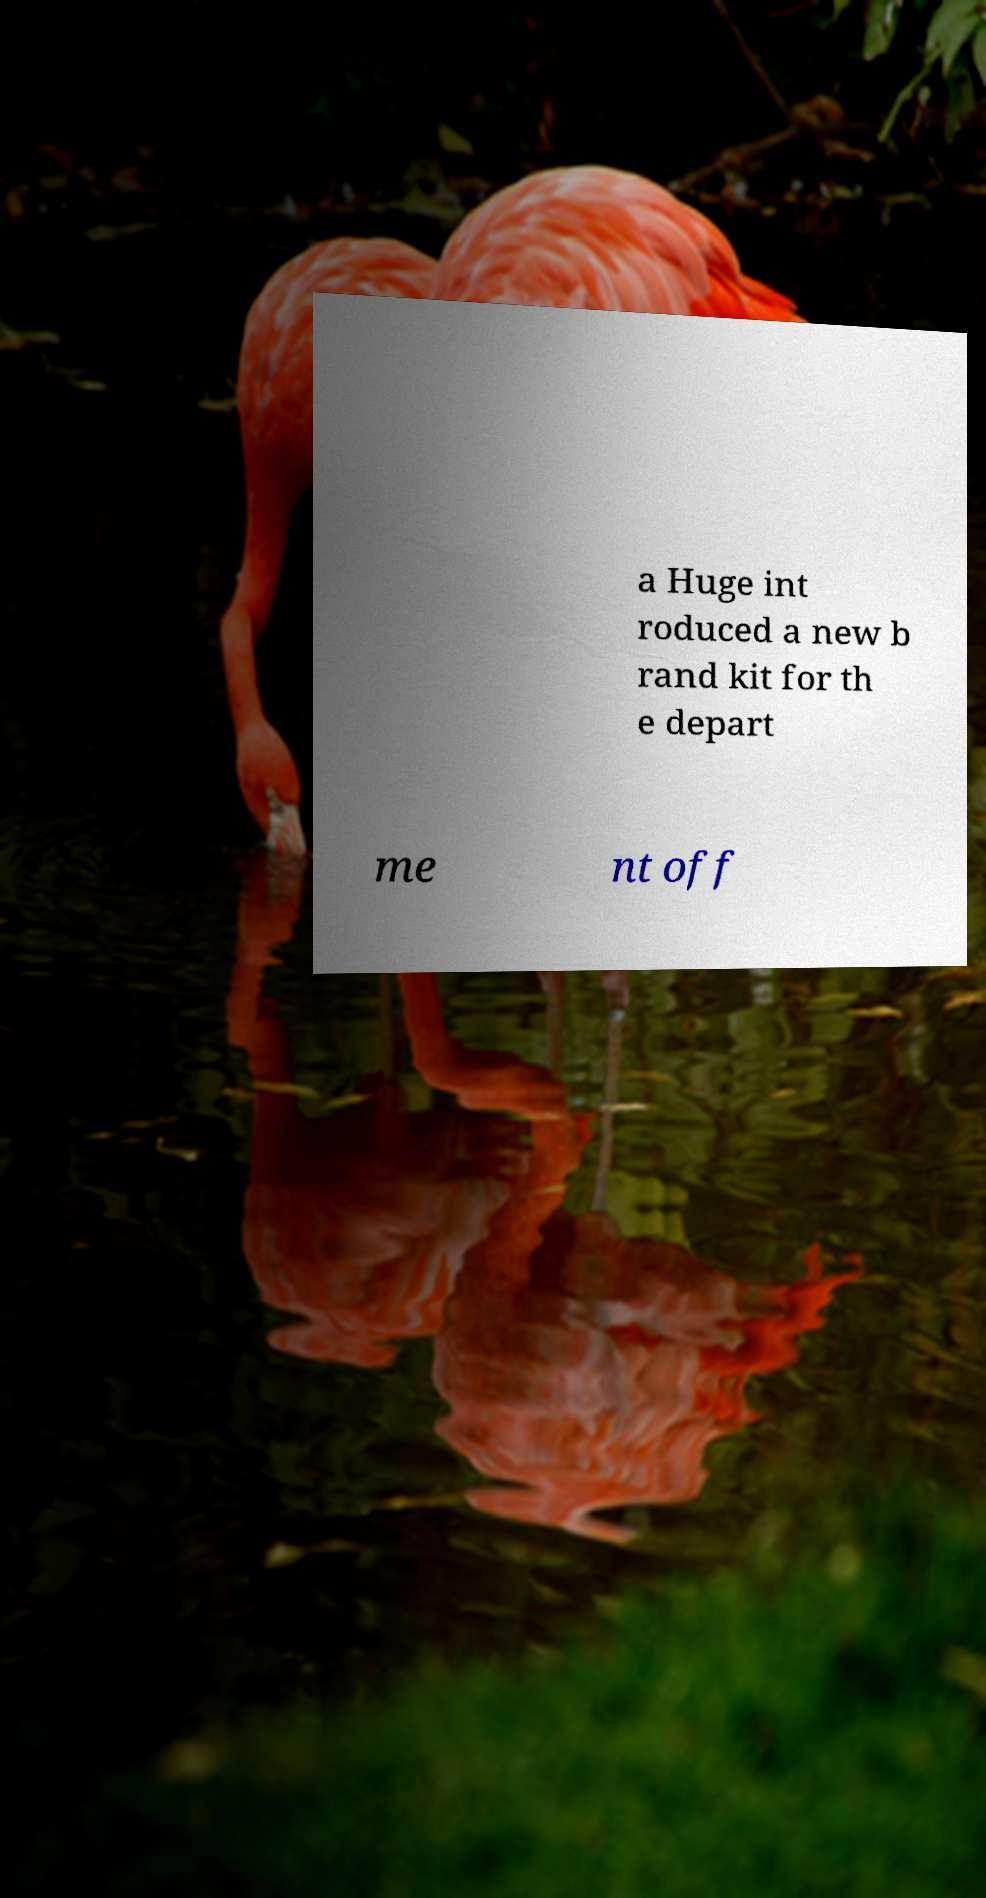Could you assist in decoding the text presented in this image and type it out clearly? a Huge int roduced a new b rand kit for th e depart me nt off 